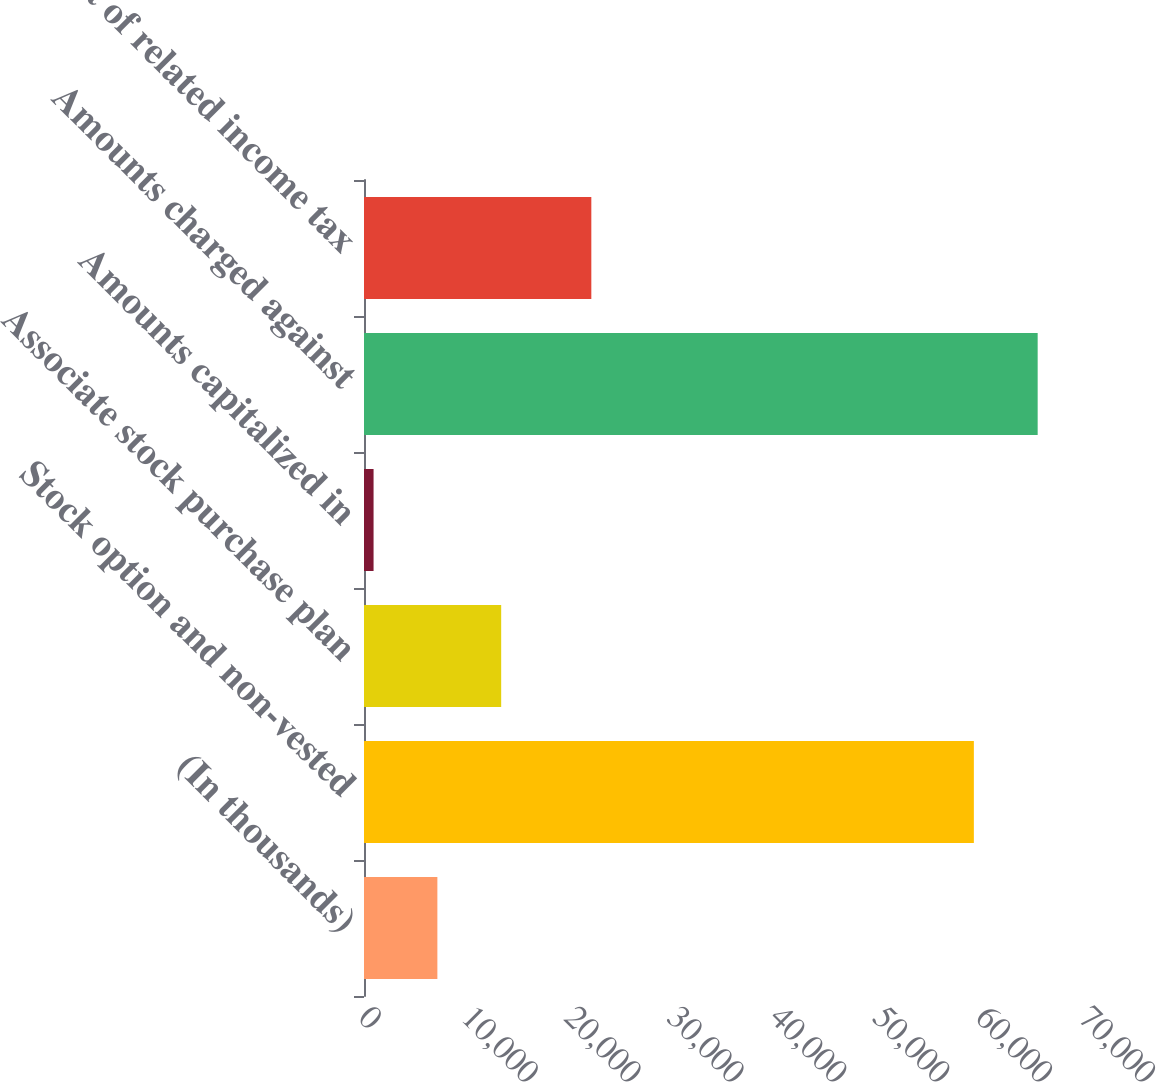Convert chart to OTSL. <chart><loc_0><loc_0><loc_500><loc_500><bar_chart><fcel>(In thousands)<fcel>Stock option and non-vested<fcel>Associate stock purchase plan<fcel>Amounts capitalized in<fcel>Amounts charged against<fcel>Amount of related income tax<nl><fcel>7133.5<fcel>59292<fcel>13337<fcel>930<fcel>65495.5<fcel>22101<nl></chart> 